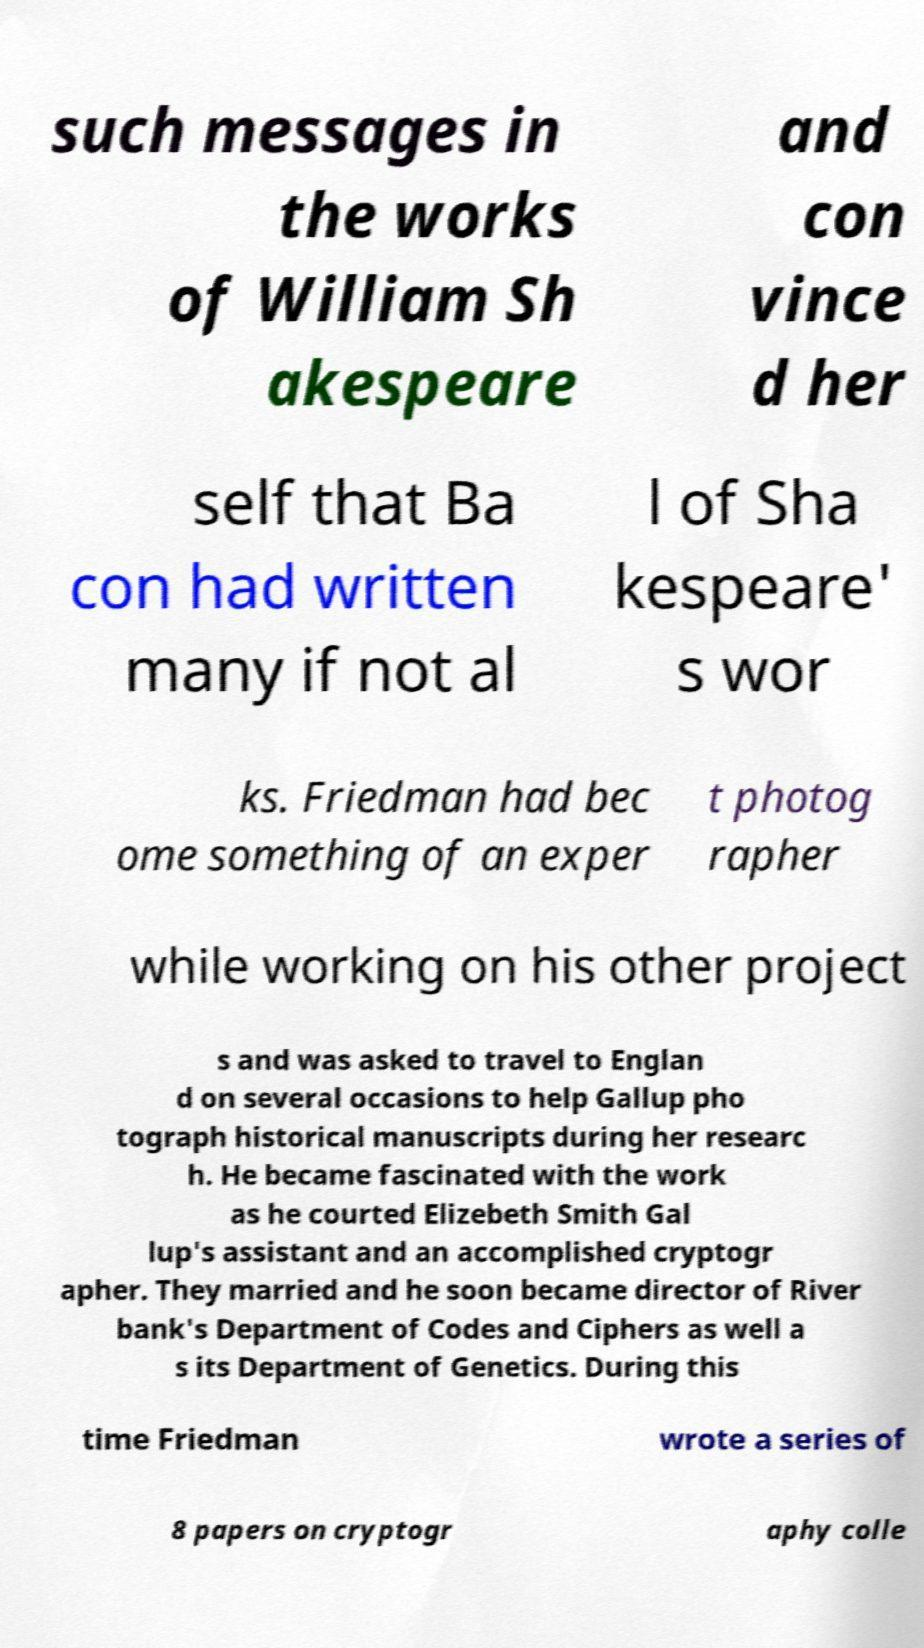Please identify and transcribe the text found in this image. such messages in the works of William Sh akespeare and con vince d her self that Ba con had written many if not al l of Sha kespeare' s wor ks. Friedman had bec ome something of an exper t photog rapher while working on his other project s and was asked to travel to Englan d on several occasions to help Gallup pho tograph historical manuscripts during her researc h. He became fascinated with the work as he courted Elizebeth Smith Gal lup's assistant and an accomplished cryptogr apher. They married and he soon became director of River bank's Department of Codes and Ciphers as well a s its Department of Genetics. During this time Friedman wrote a series of 8 papers on cryptogr aphy colle 